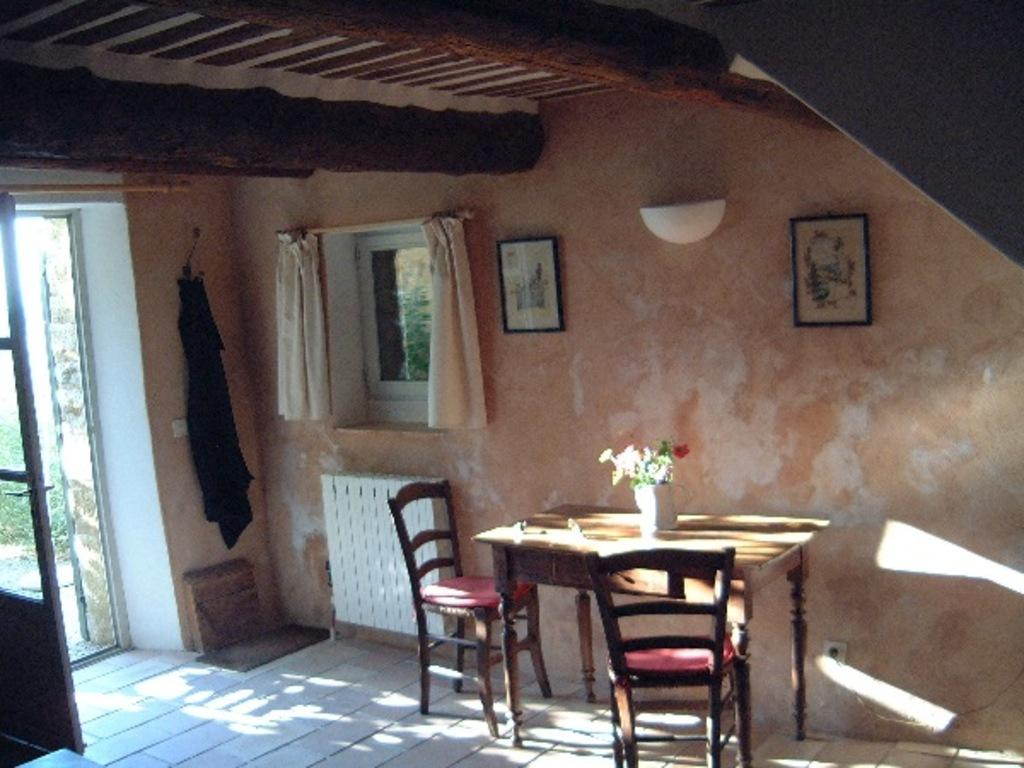What type of space is depicted in the image? The image is of a room. What feature allows natural light to enter the room? There is a window in the room. How can one enter or exit the room? There is a door in the room. What is hanging on the wall in the image? There are two frames on the wall. What type of furniture is present in the room? There are two chairs on the floor and a table in the room. What can be found on the table in the image? There is a flower pot on the table. How many girls are playing on the island in the image? There is no island or girl present in the image; it depicts a room with various objects and furniture. What type of bead is used to decorate the frames on the wall? The provided facts do not mention any beads or decorations on the frames, so we cannot determine the type of bead used. 